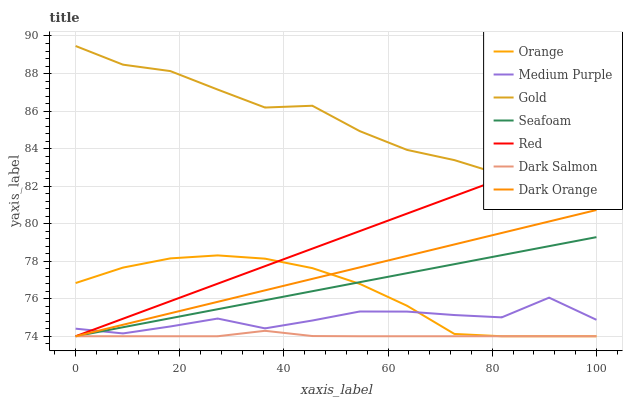Does Dark Salmon have the minimum area under the curve?
Answer yes or no. Yes. Does Gold have the maximum area under the curve?
Answer yes or no. Yes. Does Seafoam have the minimum area under the curve?
Answer yes or no. No. Does Seafoam have the maximum area under the curve?
Answer yes or no. No. Is Seafoam the smoothest?
Answer yes or no. Yes. Is Medium Purple the roughest?
Answer yes or no. Yes. Is Gold the smoothest?
Answer yes or no. No. Is Gold the roughest?
Answer yes or no. No. Does Gold have the lowest value?
Answer yes or no. No. Does Gold have the highest value?
Answer yes or no. Yes. Does Seafoam have the highest value?
Answer yes or no. No. Is Dark Salmon less than Gold?
Answer yes or no. Yes. Is Gold greater than Dark Orange?
Answer yes or no. Yes. Does Seafoam intersect Dark Salmon?
Answer yes or no. Yes. Is Seafoam less than Dark Salmon?
Answer yes or no. No. Is Seafoam greater than Dark Salmon?
Answer yes or no. No. Does Dark Salmon intersect Gold?
Answer yes or no. No. 